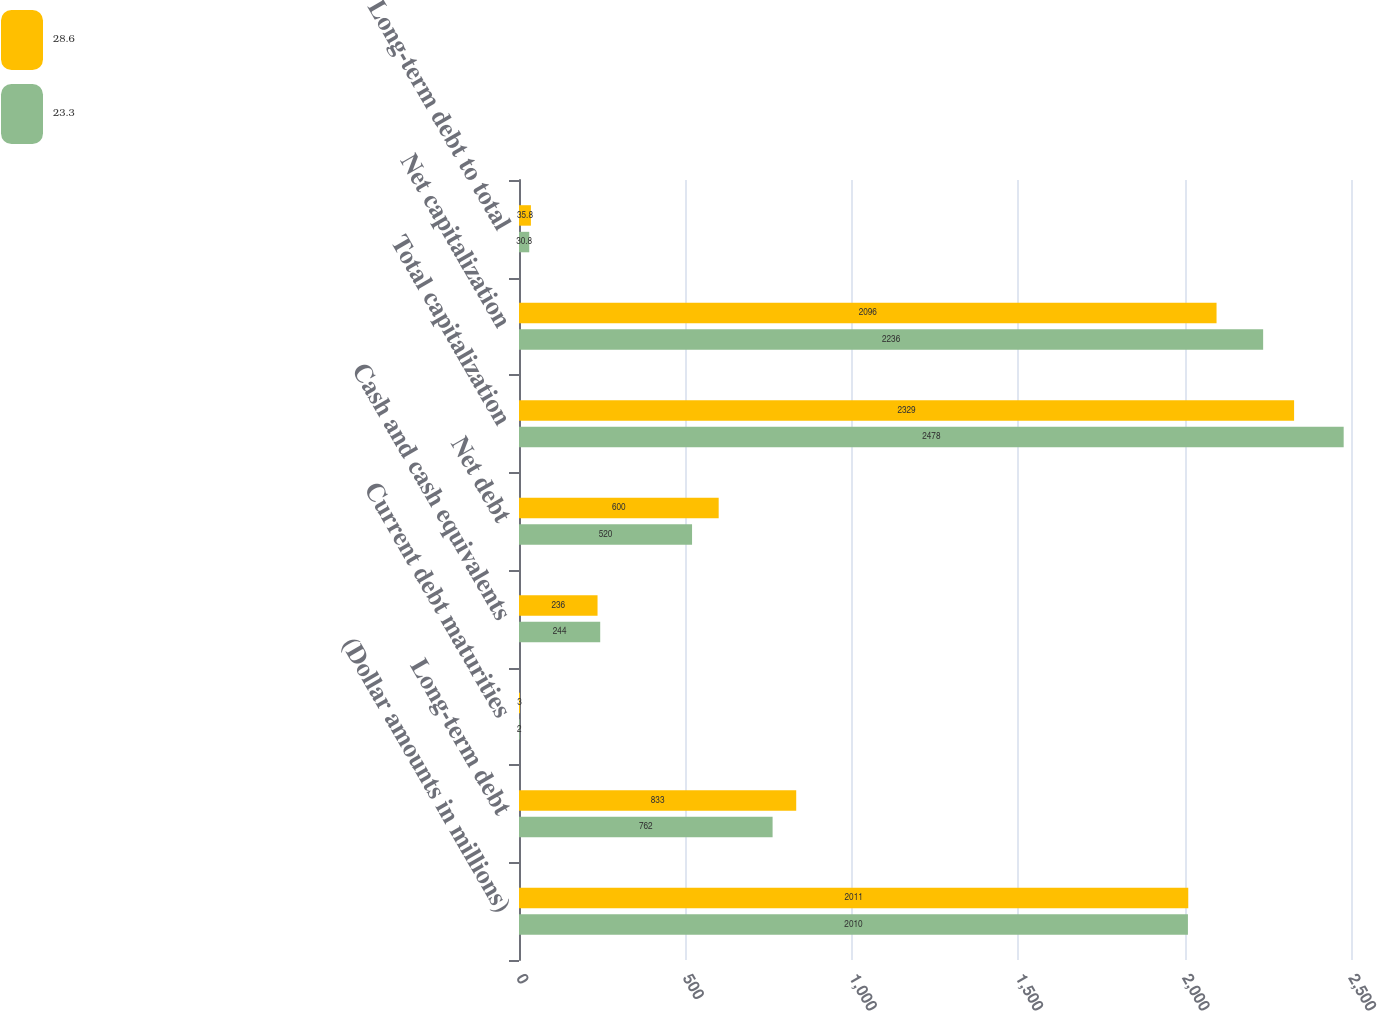Convert chart to OTSL. <chart><loc_0><loc_0><loc_500><loc_500><stacked_bar_chart><ecel><fcel>(Dollar amounts in millions)<fcel>Long-term debt<fcel>Current debt maturities<fcel>Cash and cash equivalents<fcel>Net debt<fcel>Total capitalization<fcel>Net capitalization<fcel>Long-term debt to total<nl><fcel>28.6<fcel>2011<fcel>833<fcel>3<fcel>236<fcel>600<fcel>2329<fcel>2096<fcel>35.8<nl><fcel>23.3<fcel>2010<fcel>762<fcel>2<fcel>244<fcel>520<fcel>2478<fcel>2236<fcel>30.8<nl></chart> 